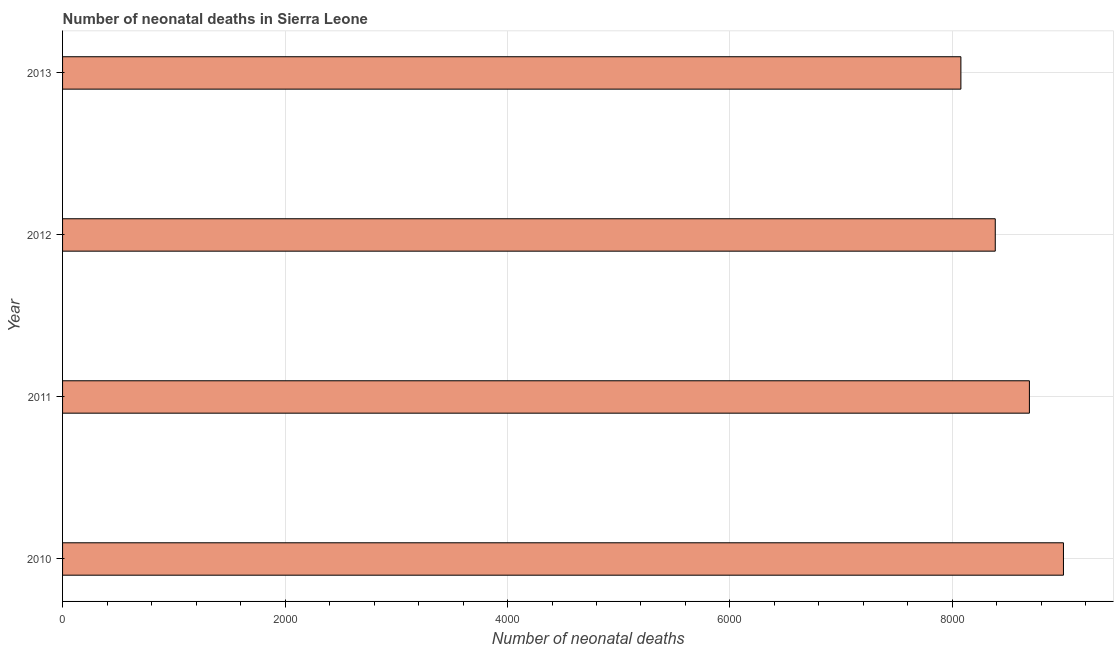What is the title of the graph?
Provide a short and direct response. Number of neonatal deaths in Sierra Leone. What is the label or title of the X-axis?
Give a very brief answer. Number of neonatal deaths. What is the number of neonatal deaths in 2012?
Give a very brief answer. 8385. Across all years, what is the maximum number of neonatal deaths?
Give a very brief answer. 8998. Across all years, what is the minimum number of neonatal deaths?
Give a very brief answer. 8076. In which year was the number of neonatal deaths minimum?
Your response must be concise. 2013. What is the sum of the number of neonatal deaths?
Provide a succinct answer. 3.42e+04. What is the difference between the number of neonatal deaths in 2010 and 2013?
Your response must be concise. 922. What is the average number of neonatal deaths per year?
Provide a succinct answer. 8537. What is the median number of neonatal deaths?
Provide a short and direct response. 8538.5. Do a majority of the years between 2010 and 2012 (inclusive) have number of neonatal deaths greater than 4400 ?
Your answer should be very brief. Yes. What is the ratio of the number of neonatal deaths in 2011 to that in 2012?
Keep it short and to the point. 1.04. Is the number of neonatal deaths in 2011 less than that in 2012?
Your answer should be compact. No. What is the difference between the highest and the second highest number of neonatal deaths?
Provide a short and direct response. 306. Is the sum of the number of neonatal deaths in 2010 and 2012 greater than the maximum number of neonatal deaths across all years?
Offer a terse response. Yes. What is the difference between the highest and the lowest number of neonatal deaths?
Make the answer very short. 922. How many bars are there?
Your response must be concise. 4. Are all the bars in the graph horizontal?
Keep it short and to the point. Yes. How many years are there in the graph?
Your answer should be compact. 4. What is the Number of neonatal deaths of 2010?
Ensure brevity in your answer.  8998. What is the Number of neonatal deaths in 2011?
Ensure brevity in your answer.  8692. What is the Number of neonatal deaths in 2012?
Your answer should be very brief. 8385. What is the Number of neonatal deaths in 2013?
Offer a terse response. 8076. What is the difference between the Number of neonatal deaths in 2010 and 2011?
Offer a very short reply. 306. What is the difference between the Number of neonatal deaths in 2010 and 2012?
Provide a short and direct response. 613. What is the difference between the Number of neonatal deaths in 2010 and 2013?
Make the answer very short. 922. What is the difference between the Number of neonatal deaths in 2011 and 2012?
Keep it short and to the point. 307. What is the difference between the Number of neonatal deaths in 2011 and 2013?
Make the answer very short. 616. What is the difference between the Number of neonatal deaths in 2012 and 2013?
Your response must be concise. 309. What is the ratio of the Number of neonatal deaths in 2010 to that in 2011?
Make the answer very short. 1.03. What is the ratio of the Number of neonatal deaths in 2010 to that in 2012?
Ensure brevity in your answer.  1.07. What is the ratio of the Number of neonatal deaths in 2010 to that in 2013?
Your response must be concise. 1.11. What is the ratio of the Number of neonatal deaths in 2011 to that in 2012?
Make the answer very short. 1.04. What is the ratio of the Number of neonatal deaths in 2011 to that in 2013?
Make the answer very short. 1.08. What is the ratio of the Number of neonatal deaths in 2012 to that in 2013?
Give a very brief answer. 1.04. 